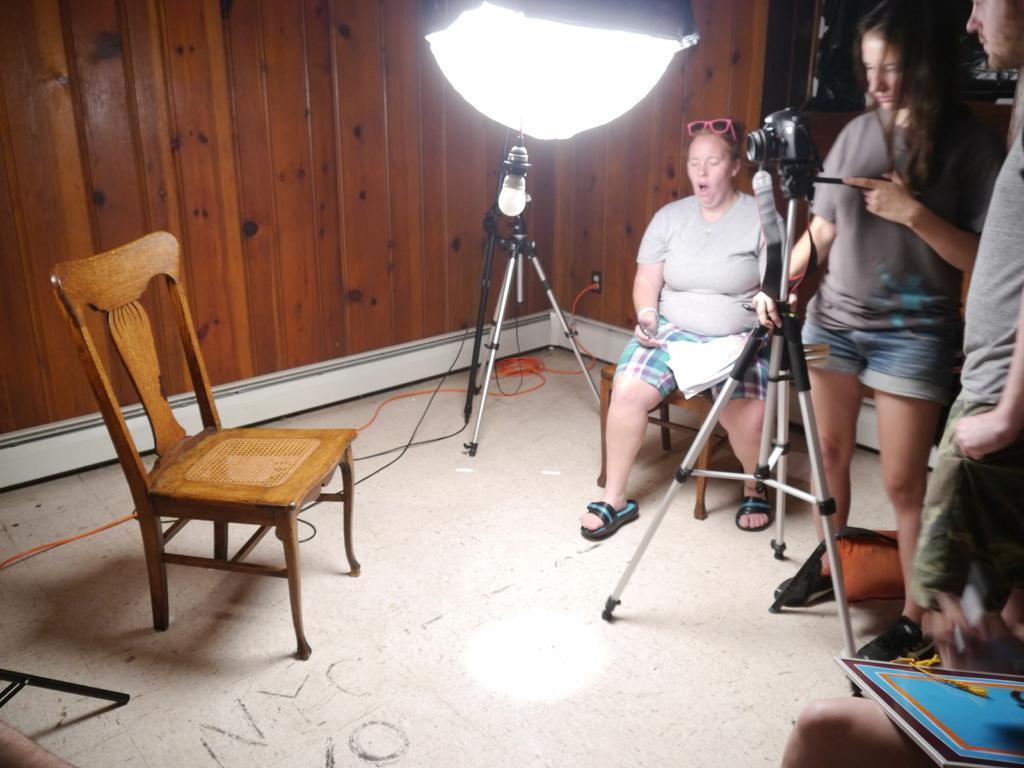In one or two sentences, can you explain what this image depicts? The image is taken in the room. On the right side of the image there are people standing. There is a camera which is attached to the stand, beside them there is a lady sitting she is holding papers. On the left there is a chair. In the background there is a wall and light. 